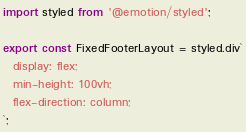Convert code to text. <code><loc_0><loc_0><loc_500><loc_500><_TypeScript_>import styled from '@emotion/styled';

export const FixedFooterLayout = styled.div`
  display: flex;
  min-height: 100vh;
  flex-direction: column;
`;
</code> 